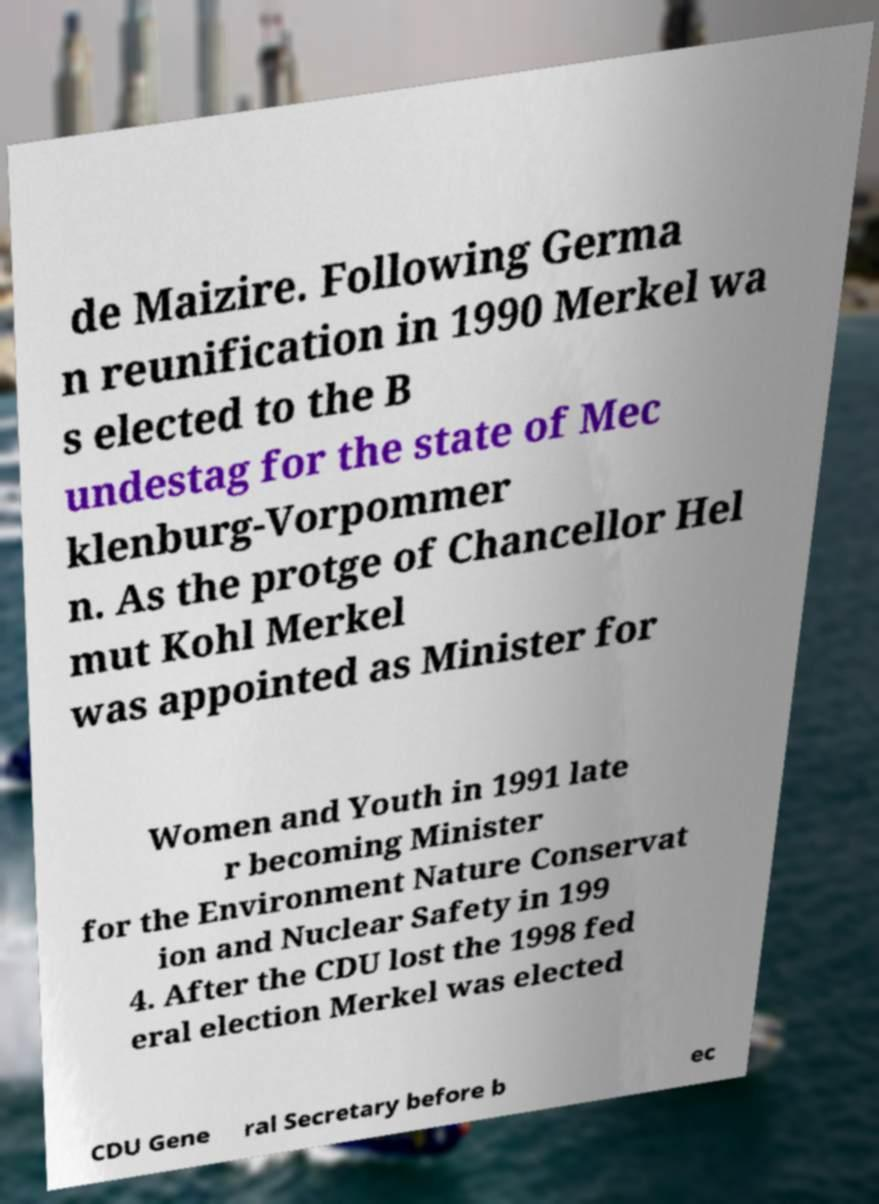Can you read and provide the text displayed in the image?This photo seems to have some interesting text. Can you extract and type it out for me? de Maizire. Following Germa n reunification in 1990 Merkel wa s elected to the B undestag for the state of Mec klenburg-Vorpommer n. As the protge of Chancellor Hel mut Kohl Merkel was appointed as Minister for Women and Youth in 1991 late r becoming Minister for the Environment Nature Conservat ion and Nuclear Safety in 199 4. After the CDU lost the 1998 fed eral election Merkel was elected CDU Gene ral Secretary before b ec 